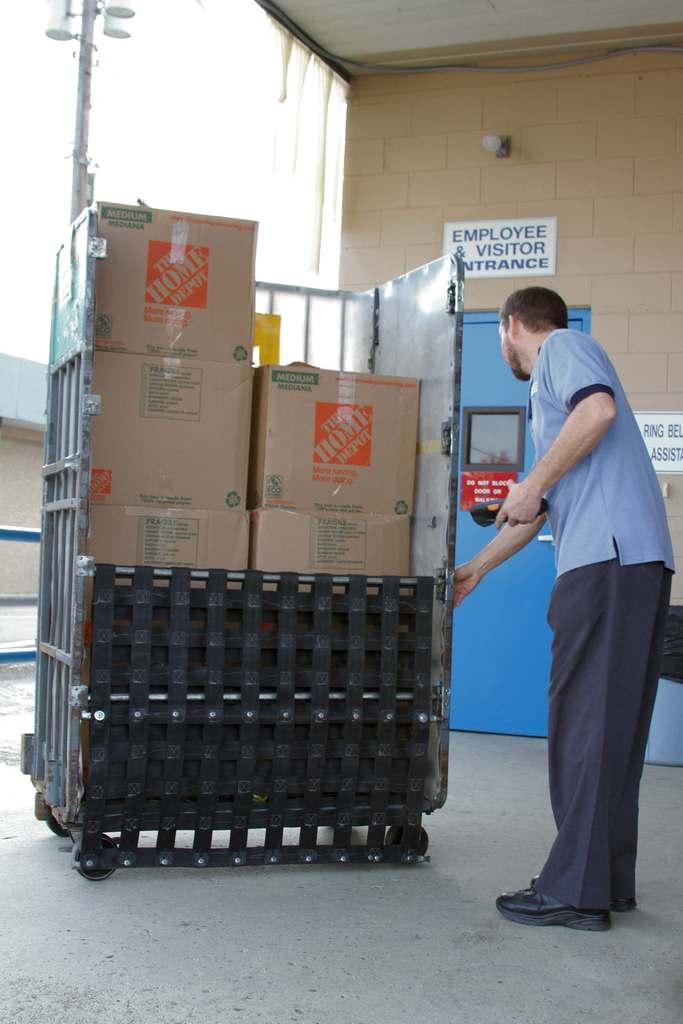Could you give a brief overview of what you see in this image? In this picture there is a person standing and holding the trolley. There are cardboard boxes in the trolley. At the back there is a building, there are posters on the wall and there is a door, at the top there is a bulb and pipe. On the left side of the image there are lights on the pole. At the top there is sky. 